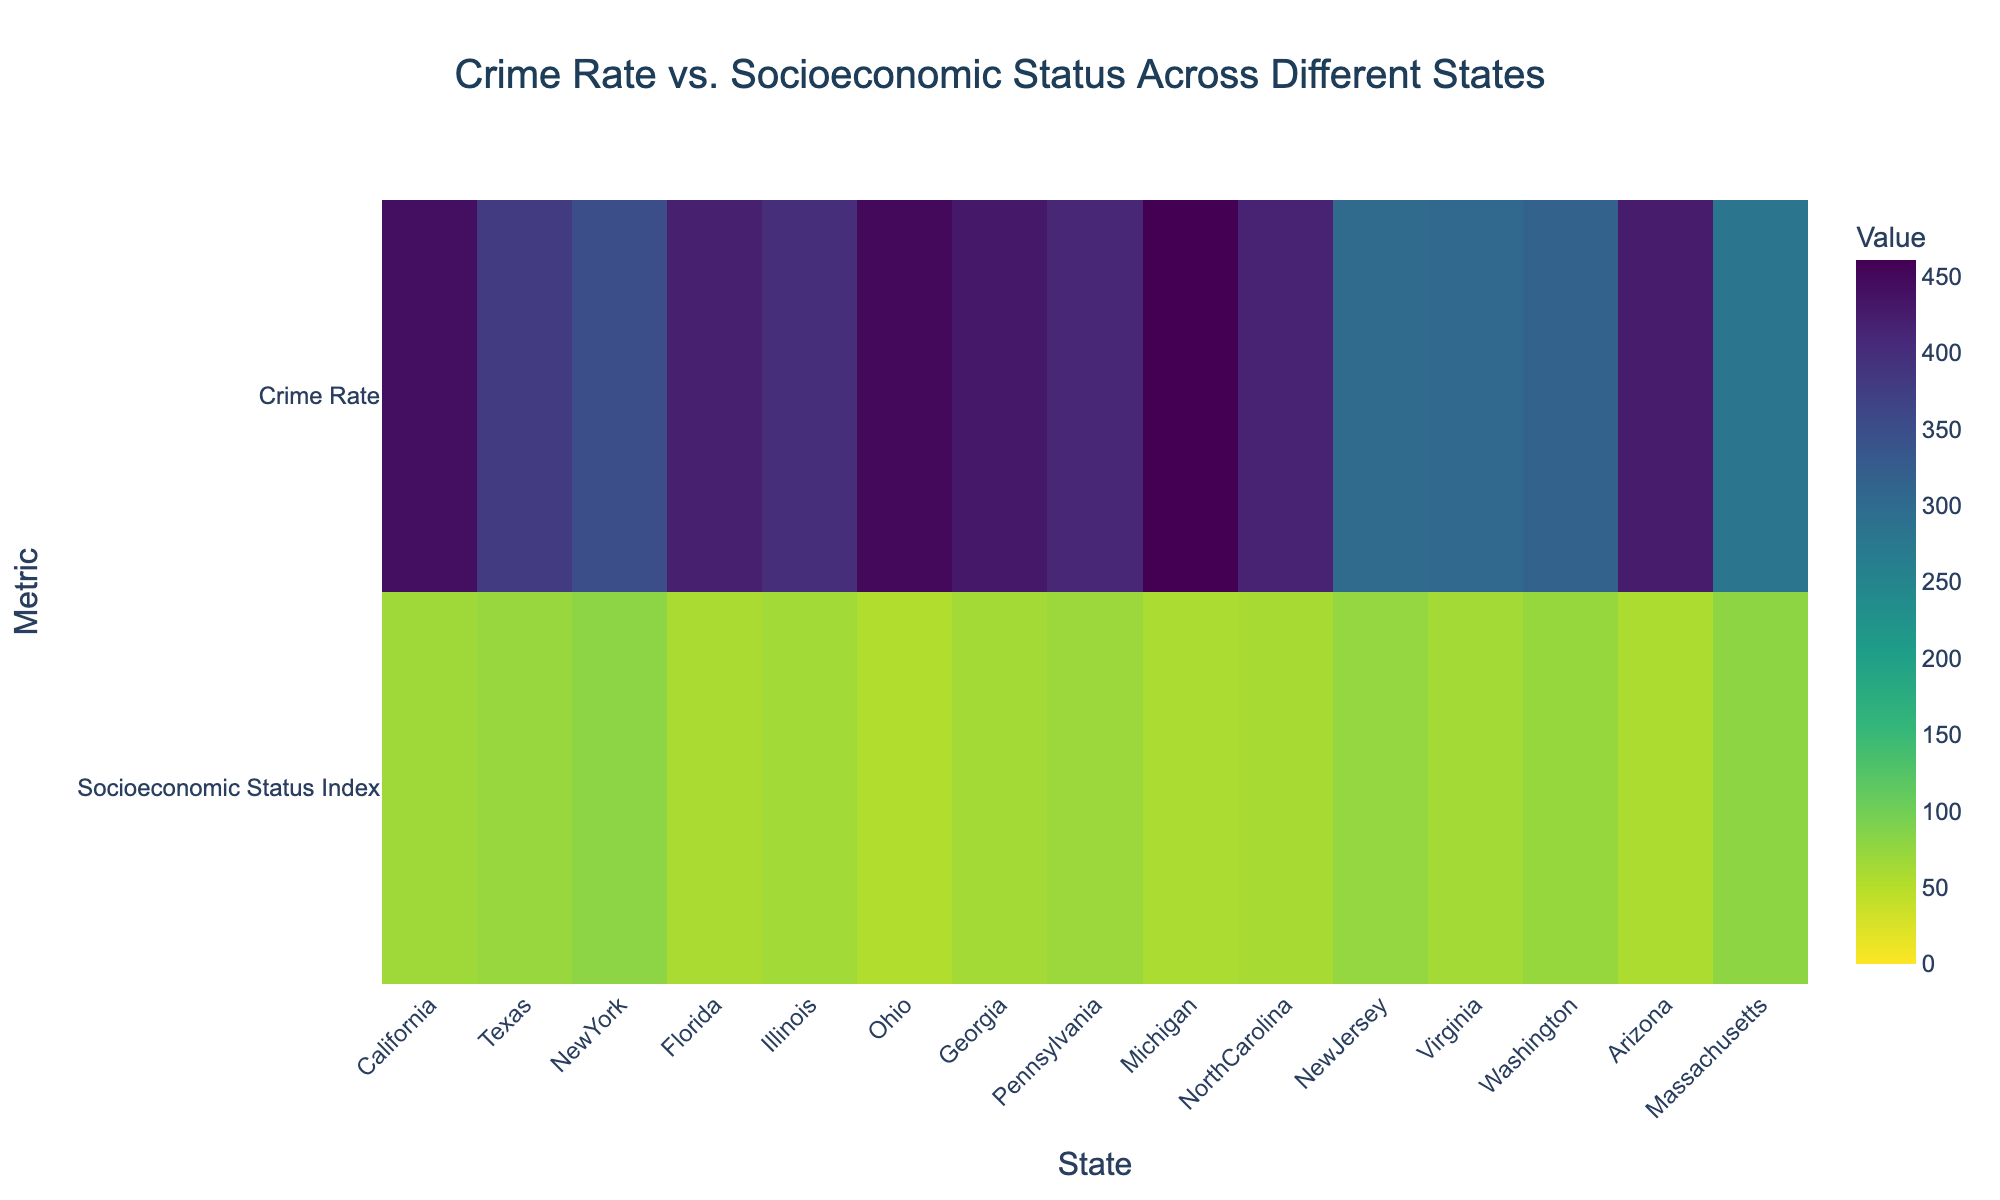what is the title of the plot? The title is displayed at the top center of the plot, specifying the purpose of the heatmap. The title is "Crime Rate vs. Socioeconomic Status Across Different States"
Answer: Crime Rate vs. Socioeconomic Status Across Different States How many states are represented in the heatmap? The x-axis denotes the states. By counting the labels on the x-axis, we can determine the number of states involved.
Answer: 15 Which state has the highest socioeconomic status index? By observing the heatmap where the values for the "Socioeconomic Status Index" row are darkest, we can identify New York and Massachusetts as having high values.
Answer: New York and Massachusetts What is the crime rate for Florida? By finding Florida on the x-axis and looking at the corresponding value in the "Crime Rate" row, we can retrieve the crime rate.
Answer: 420 Compare the crime rates of California and Virginia. Find the values in the "Crime Rate" row for California and Virginia and compare them. California's value is higher in the heatmap.
Answer: California: 442, Virginia: 305 Which state has the lowest crime rate? Look for the lightest color in the "Crime Rate" row to identify the state with the lowest crime rate. New Jersey has the lowest value.
Answer: New Jersey Is there a state with both high socioeconomic status and low crime rate? Check for states where the "Socioeconomic Status Index" row shows a high value, and the "Crime Rate" row shows a low value. Massachusetts and New Jersey meet the criteria.
Answer: Massachusetts and New Jersey What is the difference in crime rate between Ohio and New York? Find the crime rate values for Ohio and New York, then subtract New York's value from Ohio's value. Ohio has 450 and New York has 350. 450 - 350 = 100
Answer: 100 What's the average socioeconomic status index among the states? Sum all the socioeconomic status index values and divide by the number of states: (67 + 72 + 80 + 60 + 65 + 55 + 63 + 69 + 58 + 61 + 75 + 64 + 73 + 57 + 79) / 15 = 67.53
Answer: 67.53 How does the crime rate of Georgia compare to Arizona? Find Georgia and Arizona on the x-axis, then compare the corresponding crime rates. Georgia's crime rate is lower.
Answer: Georgia: 430, Arizona: 425 